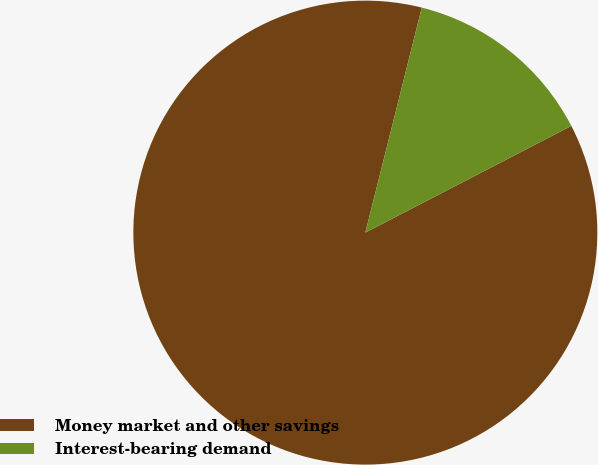Convert chart to OTSL. <chart><loc_0><loc_0><loc_500><loc_500><pie_chart><fcel>Money market and other savings<fcel>Interest-bearing demand<nl><fcel>86.52%<fcel>13.48%<nl></chart> 